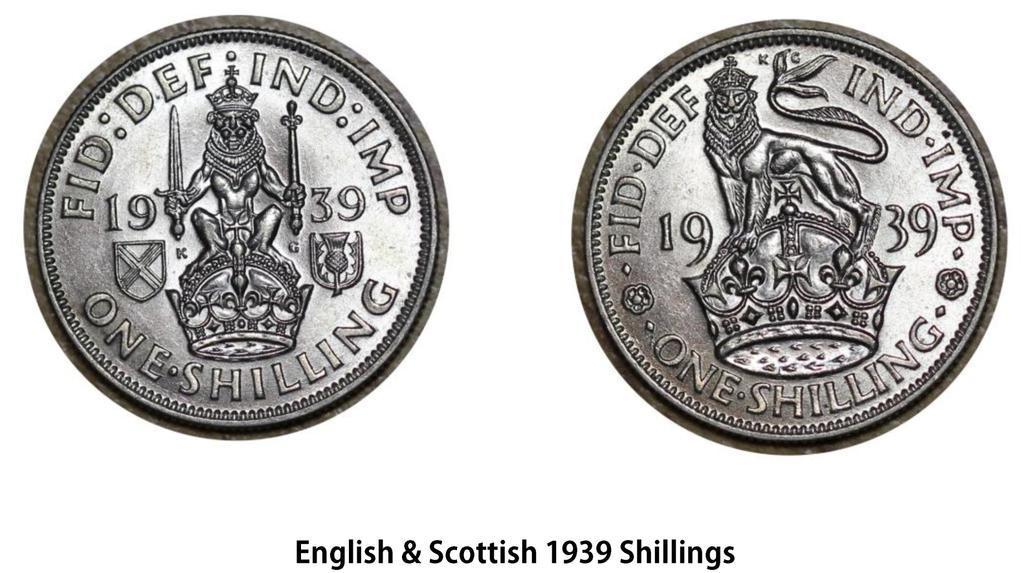<image>
Give a short and clear explanation of the subsequent image. English and Scottish 1939 Shillings is captioned below these two coins. 